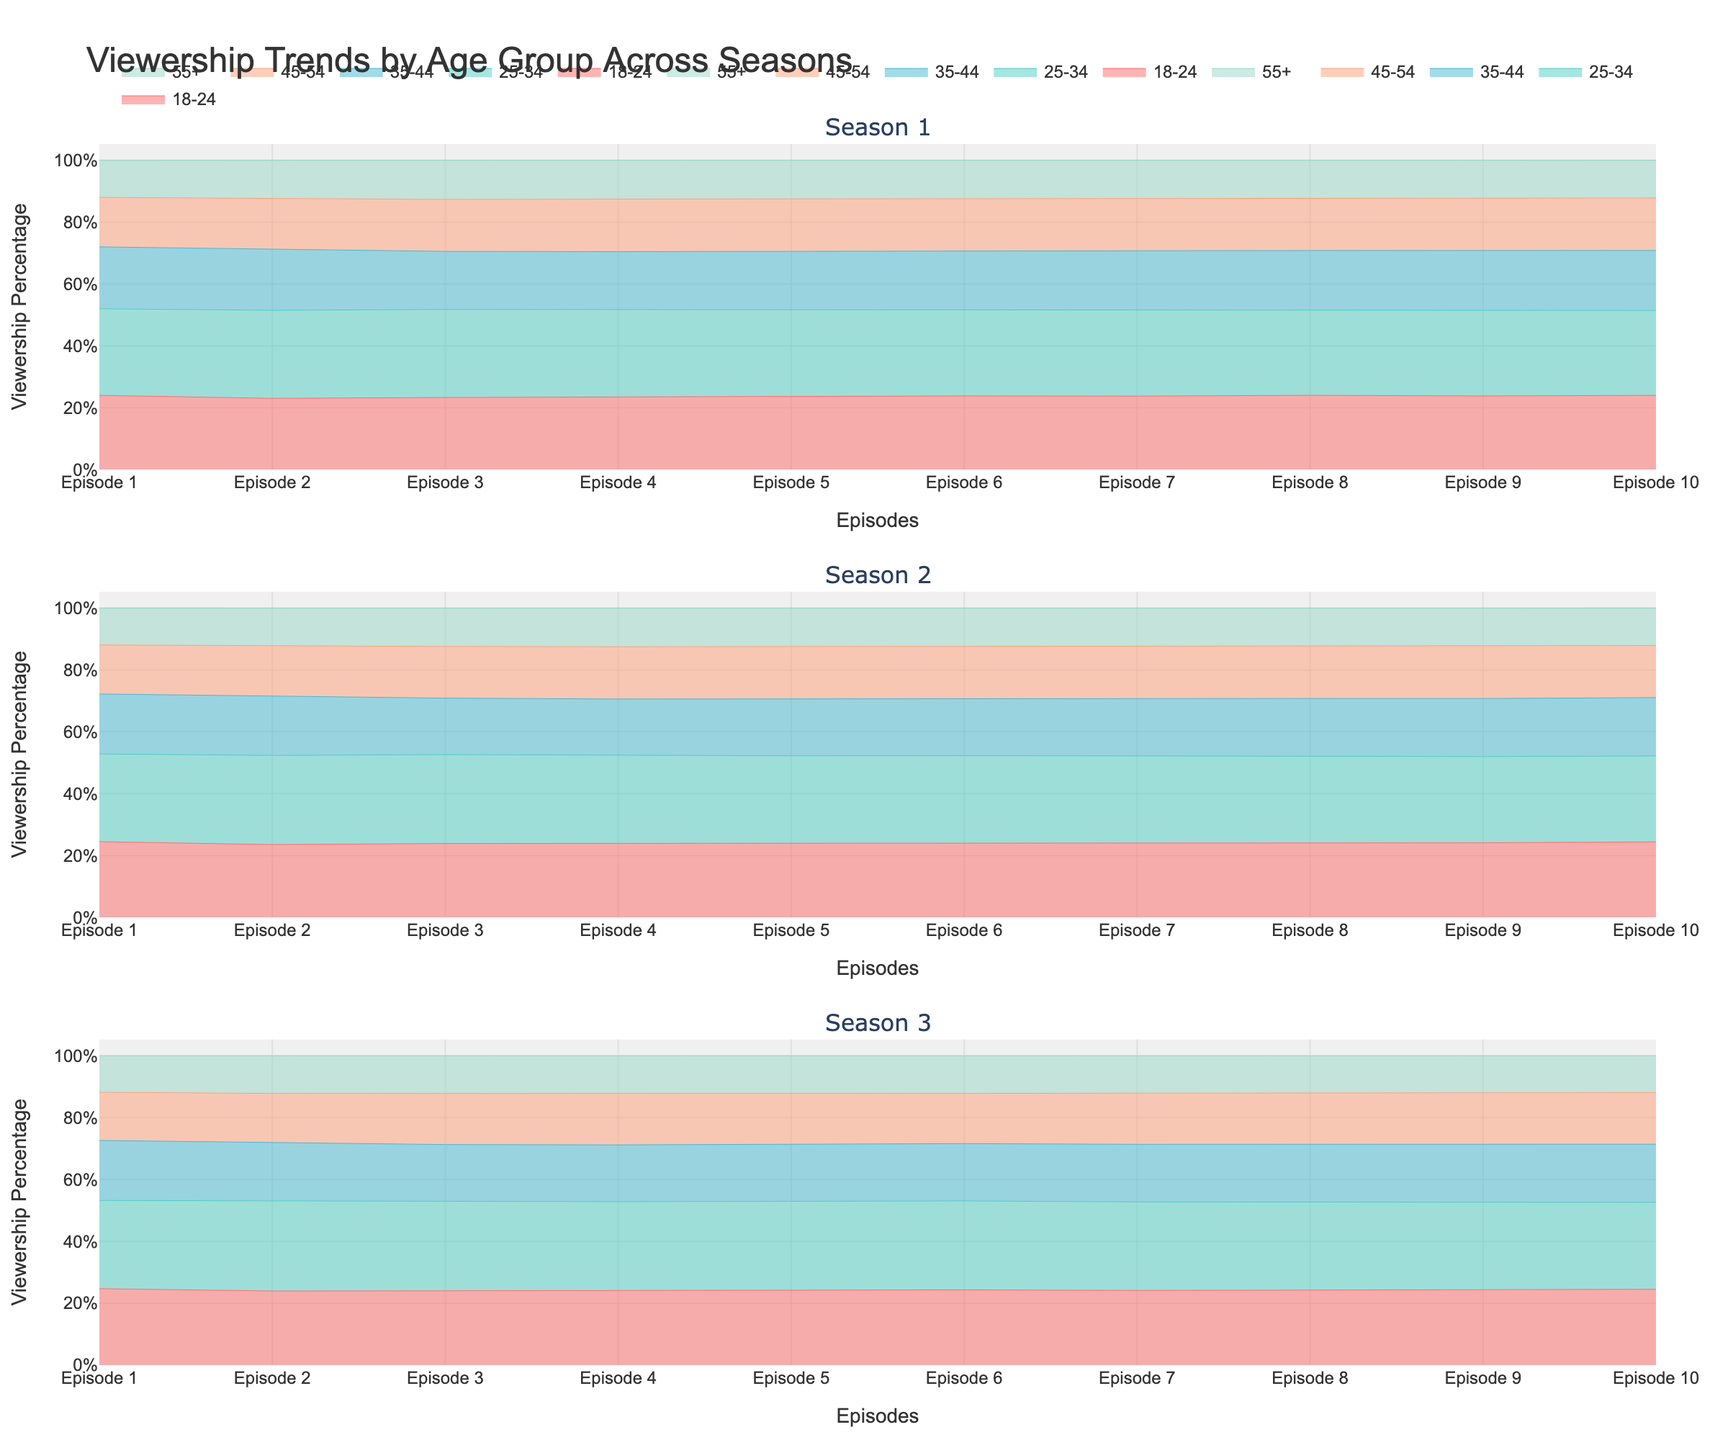What is the title of the figure? The title is displayed at the top of the figure and indicates the main subject at a glance.
Answer: Viewership Trends by Age Group Across Seasons Which age group shows consistently increasing viewership in all three seasons? By examining the stacked area charts for each season, the age group whose area uniformly increases from Episode 1 to Episode 10 is identified.
Answer: 25-34 Which season has the highest viewership percentage for the 55+ age group in Episode 10? To answer this, look at Episode 10 in each subplot and identify the relative size of the 55+ age group's area.
Answer: Season 3 What is the overall trend for the 18-24 age group across Seasons 1, 2, and 3? Inspect the areas representing the 18-24 age group in each subplot to see if they generally increase, decrease, or remain stable.
Answer: Increasing Compare the viewership trend of the 35-44 age group between Seasons 1 and 3. Examine the areas representing the 35-44 age group across all episodes in both subplots; note the relative changes.
Answer: Season 3 shows a more stable trend Which age group has the most fluctuating viewership percentage across episodes in any season? Identify the age group whose area changes significantly from one episode to another in any of the subplots.
Answer: 35-44 in Seasons 1 and 3 During which episodes of Season 2 does the 45-54 age group surpass the 18-24 age group in viewership percentage? Compare the areas of the two age groups at each episode in the Season 2 subplot to find episodes where the 45-54 group is larger.
Answer: Episodes 5 to 10 What is the combined viewership percentage of the 18-24 and 25-34 age groups in Episode 10 of Season 1? Sum the percentages of the areas for the 18-24 and 25-34 age groups in Episode 10 of the Season 1 subplot.
Answer: Around 58% Which episode in Season 3 has the highest viewership percentage for the 25-34 age group, and what is that percentage approximately? Identify the peak area for the 25-34 age group in the Season 3 subplot and approximate its value.
Answer: Episode 10, approximately 40% How does the viewership trend of the 45-54 age group in Season 3 compare to the same age group in Season 2? Analyze the relative area occupied by the 45-54 age group in each episode for both seasons to compare their trends.
Answer: They are similar but with a slight increase in Season 3 